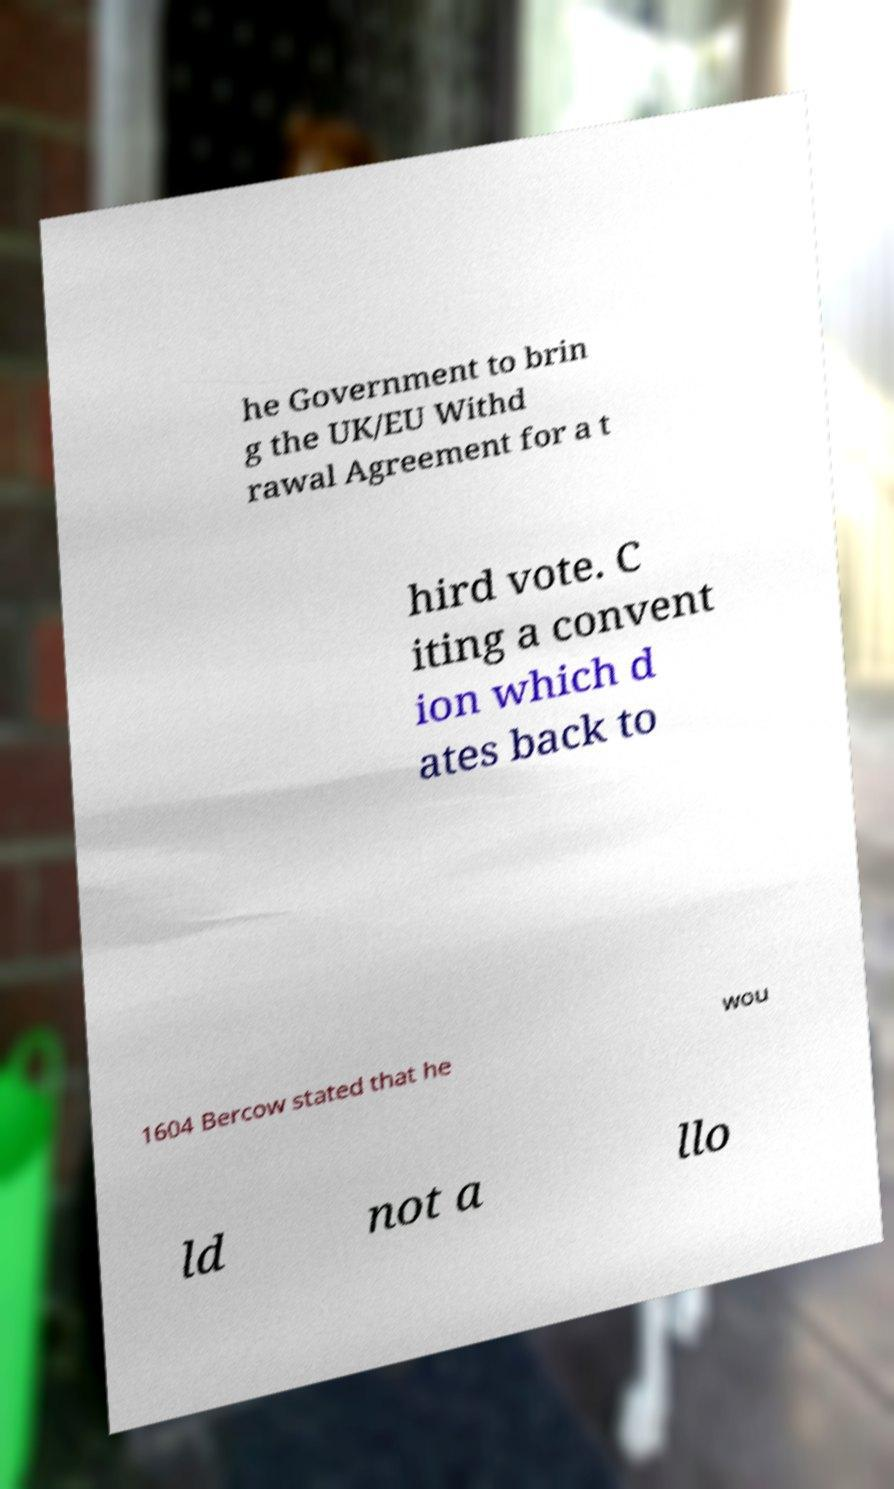Please read and relay the text visible in this image. What does it say? he Government to brin g the UK/EU Withd rawal Agreement for a t hird vote. C iting a convent ion which d ates back to 1604 Bercow stated that he wou ld not a llo 